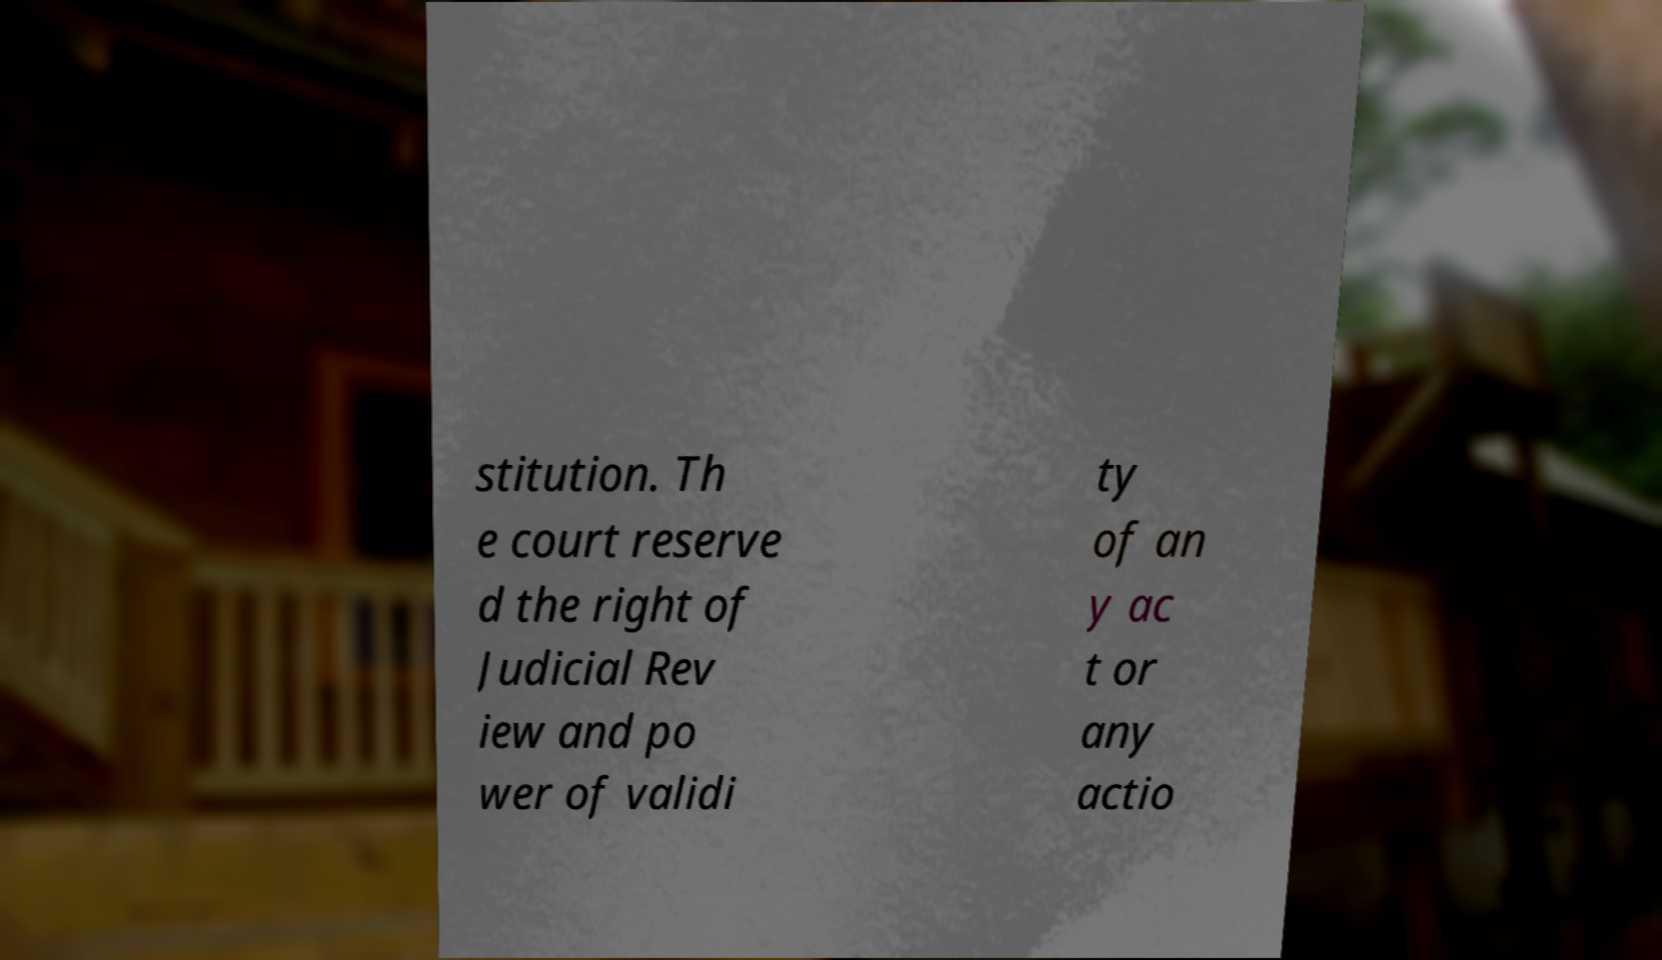Please read and relay the text visible in this image. What does it say? stitution. Th e court reserve d the right of Judicial Rev iew and po wer of validi ty of an y ac t or any actio 